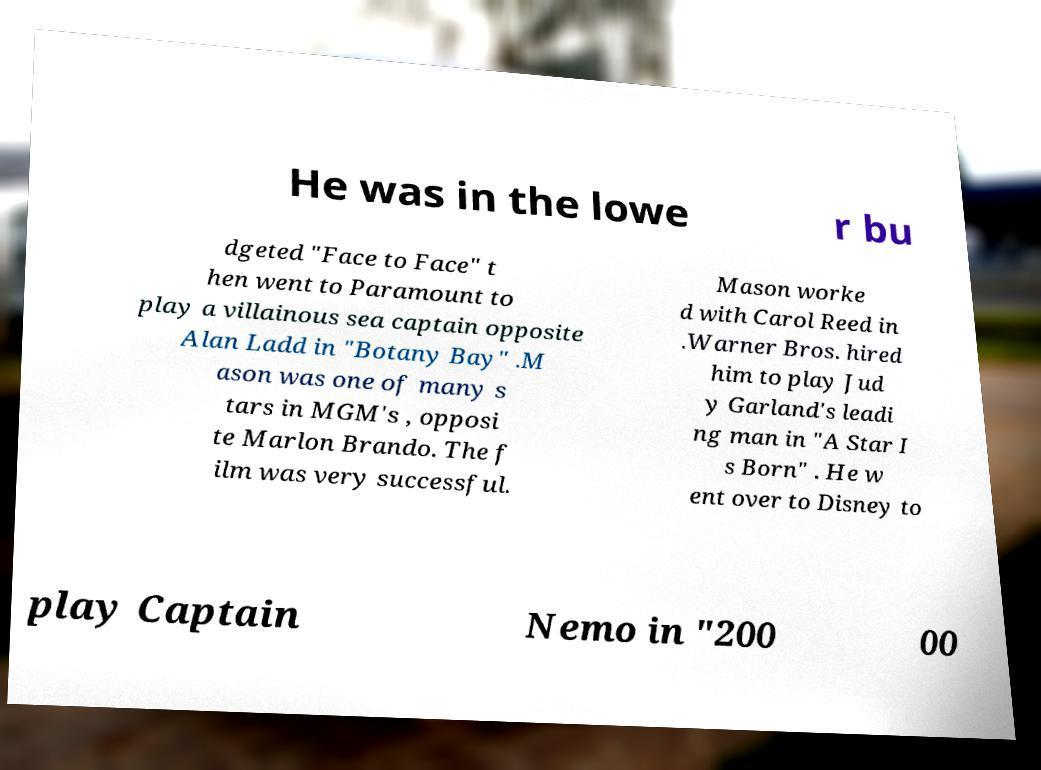Could you extract and type out the text from this image? He was in the lowe r bu dgeted "Face to Face" t hen went to Paramount to play a villainous sea captain opposite Alan Ladd in "Botany Bay" .M ason was one of many s tars in MGM's , opposi te Marlon Brando. The f ilm was very successful. Mason worke d with Carol Reed in .Warner Bros. hired him to play Jud y Garland's leadi ng man in "A Star I s Born" . He w ent over to Disney to play Captain Nemo in "200 00 